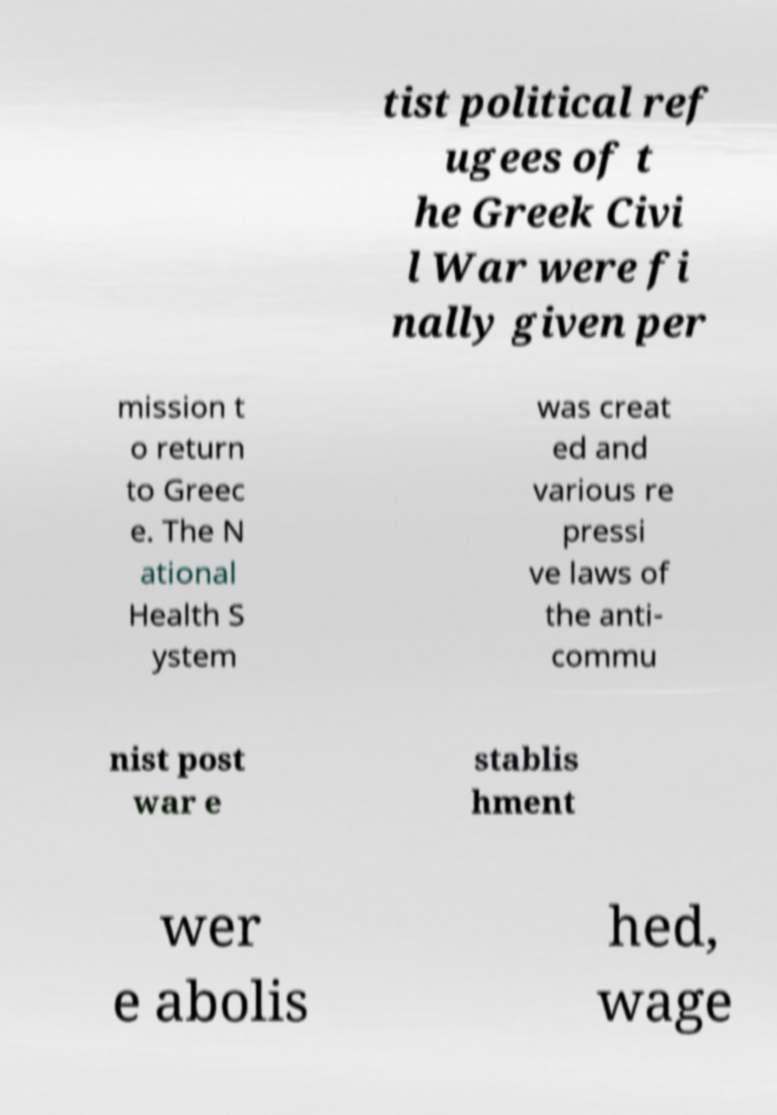For documentation purposes, I need the text within this image transcribed. Could you provide that? tist political ref ugees of t he Greek Civi l War were fi nally given per mission t o return to Greec e. The N ational Health S ystem was creat ed and various re pressi ve laws of the anti- commu nist post war e stablis hment wer e abolis hed, wage 